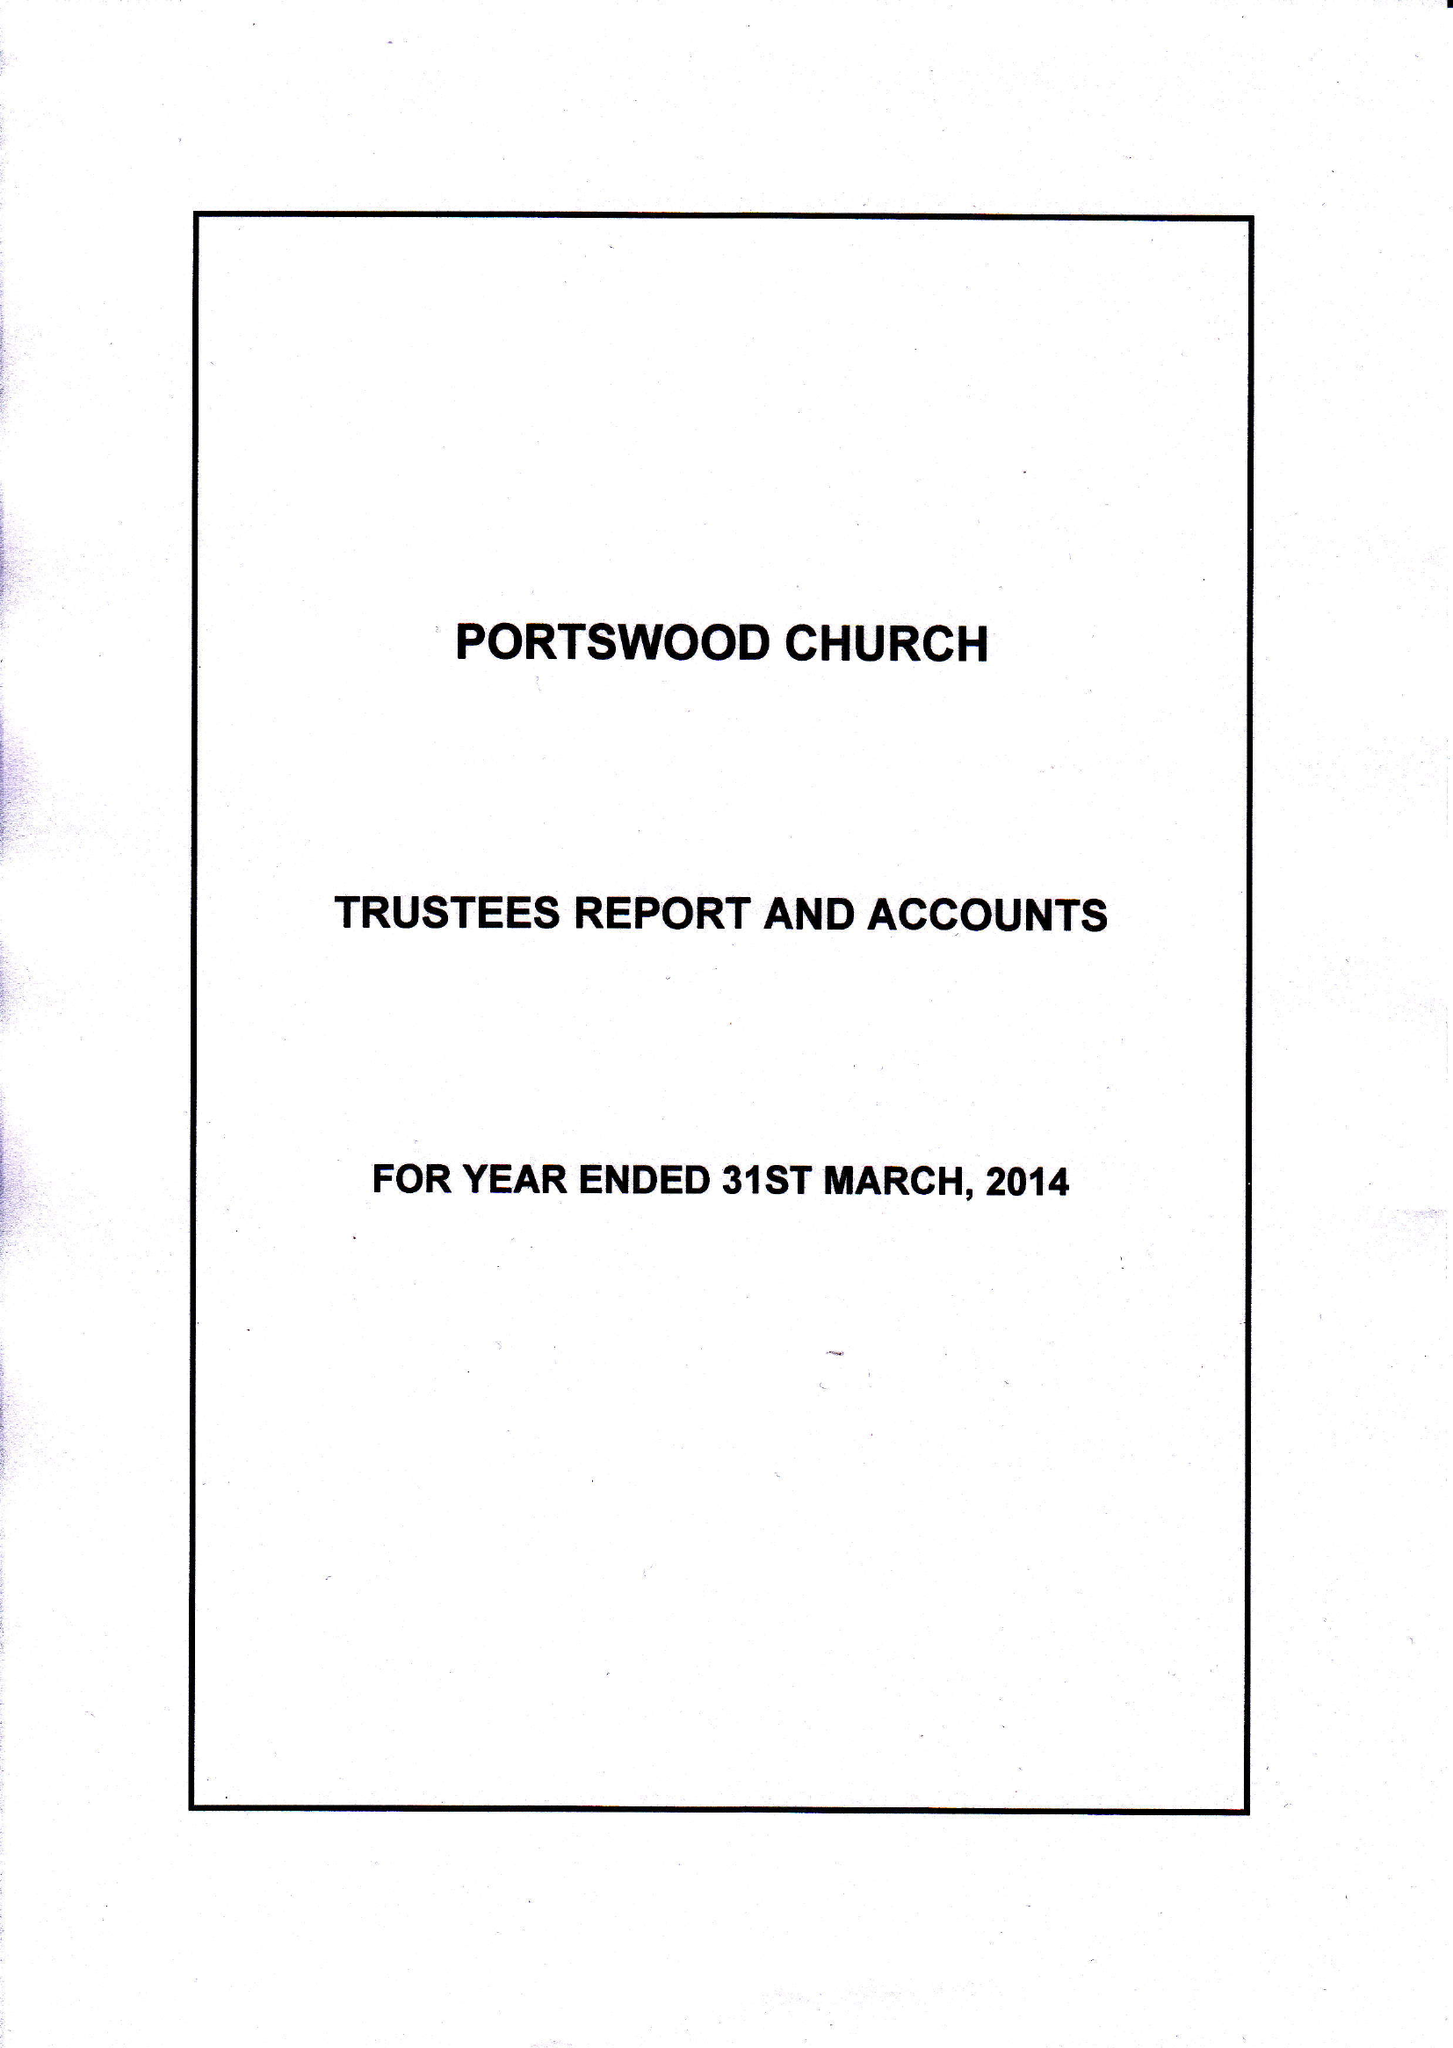What is the value for the charity_number?
Answer the question using a single word or phrase. 248769 